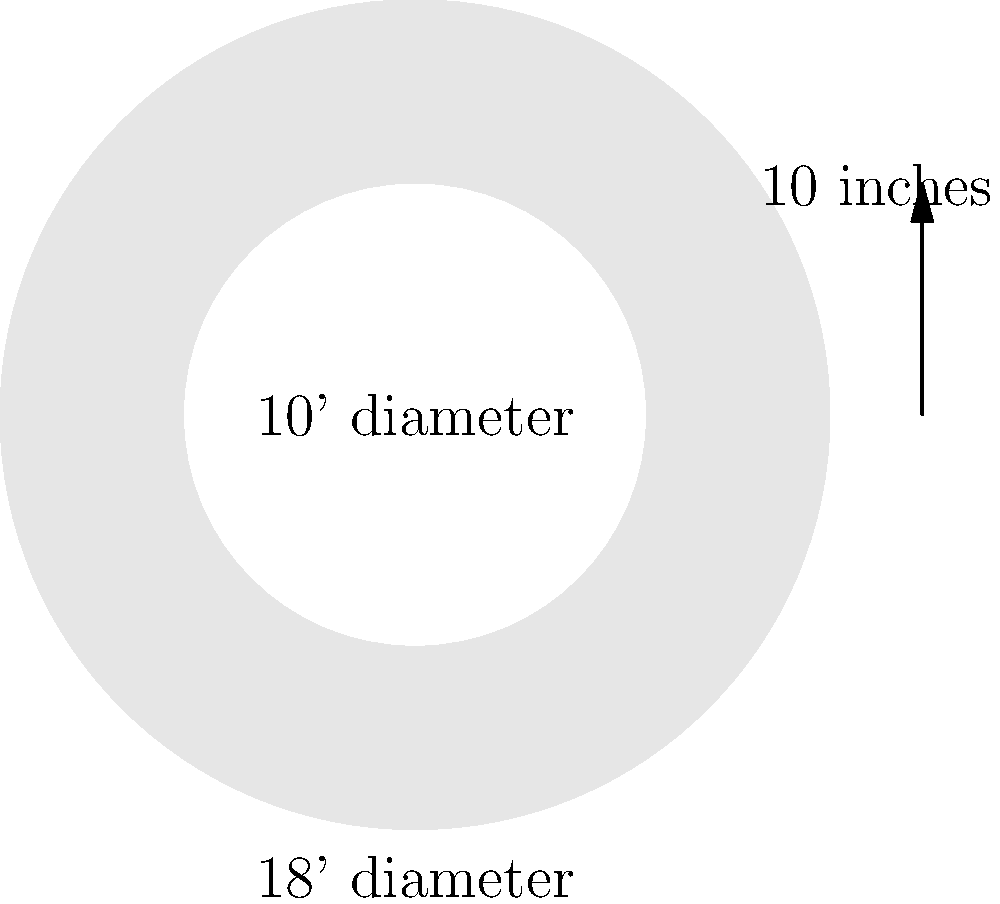As a groundskeeper, you need to construct a new pitcher's mound. The mound has a total diameter of 18 feet, with a flat top diameter of 10 feet. The height of the mound is 10 inches. Assuming the mound is a perfect frustum (truncated cone), calculate the volume of soil needed in cubic feet. Round your answer to the nearest whole number. To calculate the volume of soil needed for the mound, we'll use the formula for the volume of a frustum:

$$V = \frac{1}{3}\pi h(R^2 + r^2 + Rr)$$

Where:
$V$ = volume
$h$ = height
$R$ = radius of the base
$r$ = radius of the top

Step 1: Convert dimensions to feet
- Height: $h = 10 \text{ inches} = \frac{10}{12} = 0.8333 \text{ feet}$
- Base radius: $R = 18 \text{ feet} \div 2 = 9 \text{ feet}$
- Top radius: $r = 10 \text{ feet} \div 2 = 5 \text{ feet}$

Step 2: Plug values into the formula
$$V = \frac{1}{3}\pi(0.8333)(9^2 + 5^2 + 9 \times 5)$$

Step 3: Calculate
$$V = \frac{1}{3}\pi(0.8333)(81 + 25 + 45)$$
$$V = \frac{1}{3}\pi(0.8333)(151)$$
$$V = 131.64 \text{ cubic feet}$$

Step 4: Round to the nearest whole number
$V \approx 132 \text{ cubic feet}$
Answer: 132 cubic feet 